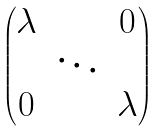<formula> <loc_0><loc_0><loc_500><loc_500>\begin{pmatrix} \lambda & & 0 \\ & \ddots & \\ 0 & & \lambda \end{pmatrix}</formula> 